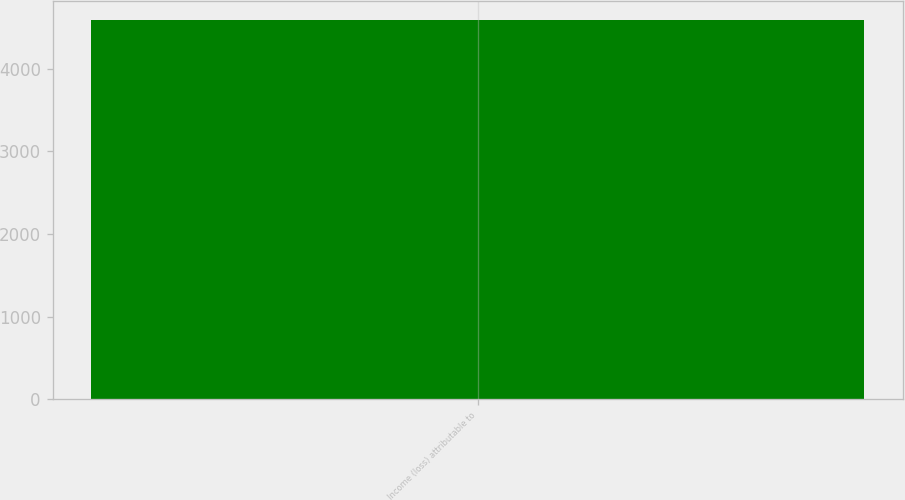Convert chart to OTSL. <chart><loc_0><loc_0><loc_500><loc_500><bar_chart><fcel>Income (loss) attributable to<nl><fcel>4584<nl></chart> 